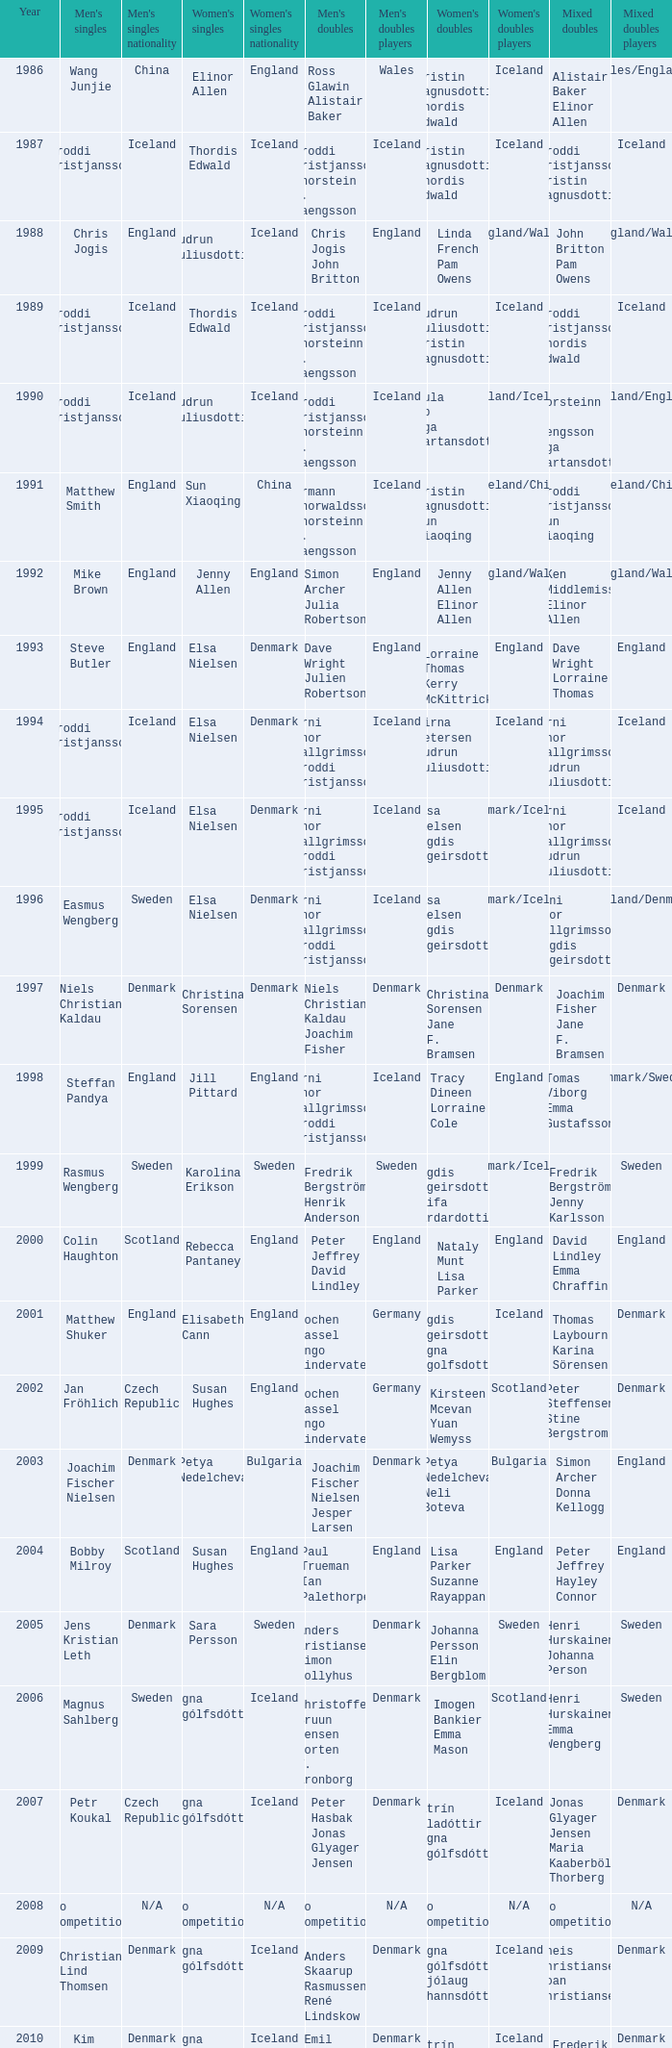In what mixed doubles did Niels Christian Kaldau play in men's singles? Joachim Fisher Jane F. Bramsen. 